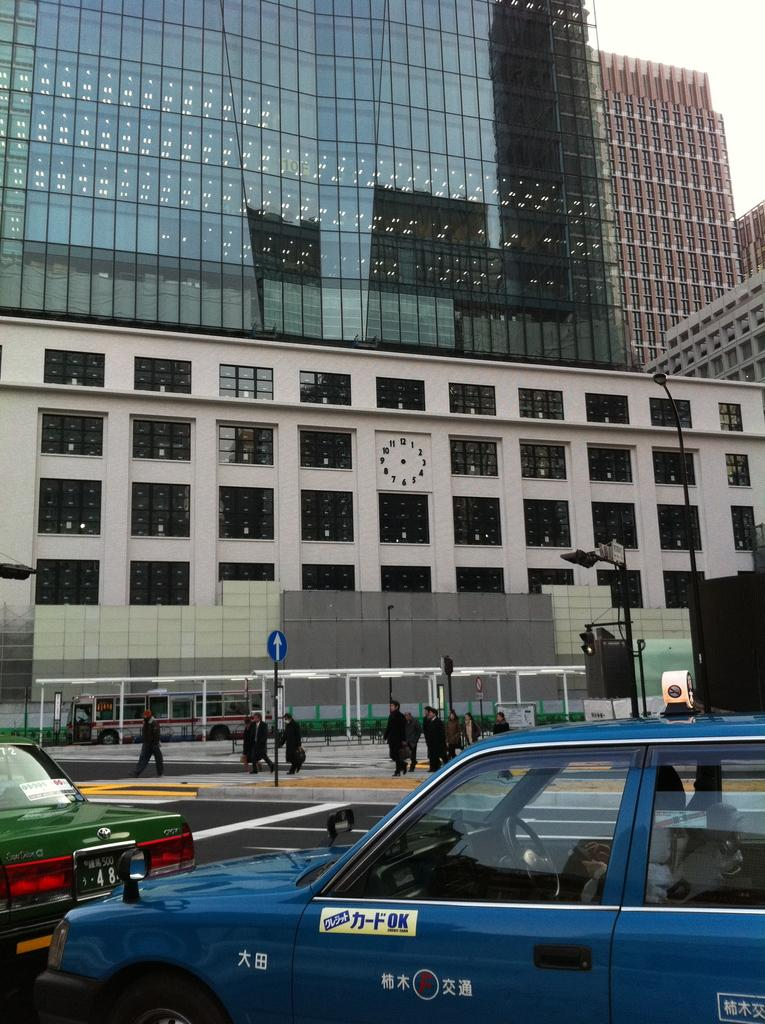What type of vehicles can be seen in the image? There are cars and a bus in the image. What other objects are present in the image? There are boards, poles, buildings, and people standing in the image. Can you describe any specific features of the cars in the image? There is writing on a car in the image. What type of scarf is the person wearing in the image? There is no person wearing a scarf in the image. How does the hair of the person in the image look? There is no person with visible hair in the image. 